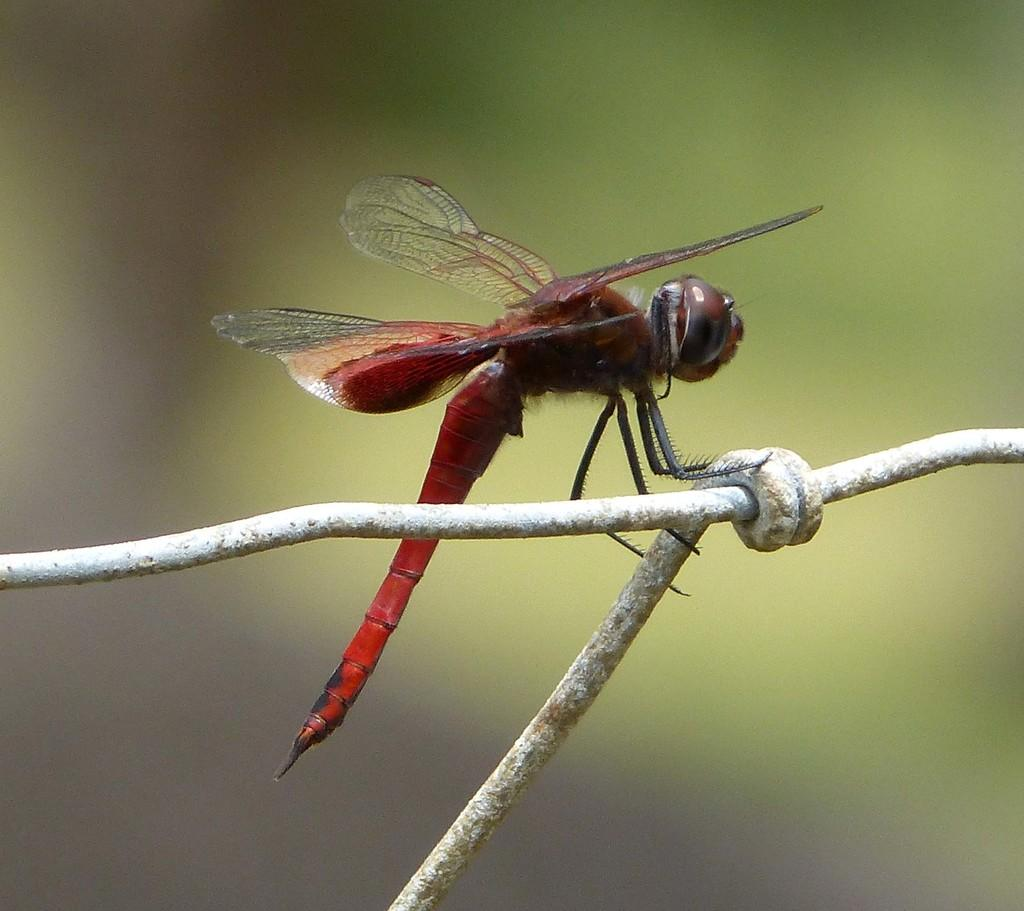What is the main subject of the image? There is an insect in the center of the image. What is the insect resting on? The insect is on a rod. Can you describe the background of the image? The background of the image is blurry. What type of drink is the insect holding in its hands in the image? There is no drink present in the image, and insects do not have hands. 